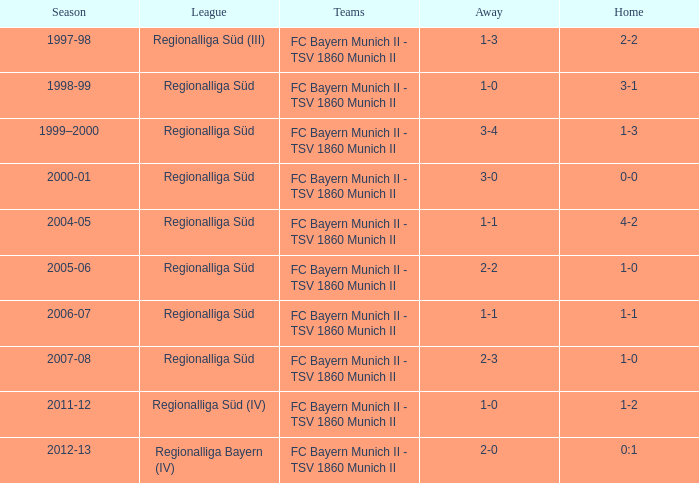Which season has the regionalliga süd (iii) league? 1997-98. 